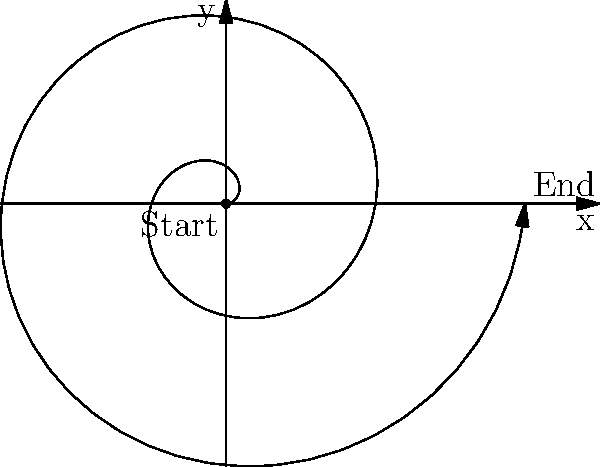In the famous chocolate conveyor belt scene from "I Love Lucy," Lucy's spiral path around the belt can be modeled using polar coordinates. If the equation $r = 0.2\theta$ represents Lucy's movement, where $r$ is in meters and $\theta$ is in radians, what is the total distance Lucy travels after completing two full revolutions around the belt? To solve this problem, we need to follow these steps:

1) First, we need to understand that two full revolutions correspond to $4\pi$ radians, as one revolution is $2\pi$ radians.

2) The formula for the arc length $s$ of a curve in polar coordinates from $\theta = a$ to $\theta = b$ is:

   $$s = \int_a^b \sqrt{r^2 + \left(\frac{dr}{d\theta}\right)^2} d\theta$$

3) In our case, $r = 0.2\theta$, so $\frac{dr}{d\theta} = 0.2$

4) Substituting these into the formula:

   $$s = \int_0^{4\pi} \sqrt{(0.2\theta)^2 + 0.2^2} d\theta$$

5) Simplifying under the square root:

   $$s = \int_0^{4\pi} \sqrt{0.04\theta^2 + 0.04} d\theta = 0.2 \int_0^{4\pi} \sqrt{\theta^2 + 1} d\theta$$

6) This integral can be solved using the substitution $\theta = \sinh u$:

   $$s = 0.2 [\theta \sqrt{\theta^2 + 1} - \ln(\theta + \sqrt{\theta^2 + 1})]_0^{4\pi}$$

7) Evaluating at the limits:

   $$s = 0.2 [4\pi \sqrt{(4\pi)^2 + 1} - \ln(4\pi + \sqrt{(4\pi)^2 + 1}) - (0 - 0)]$$

8) Calculating this (you can use a calculator for this part):

   $$s \approx 10.05 \text{ meters}$$

Thus, Lucy travels approximately 10.05 meters in two revolutions around the conveyor belt.
Answer: 10.05 meters 